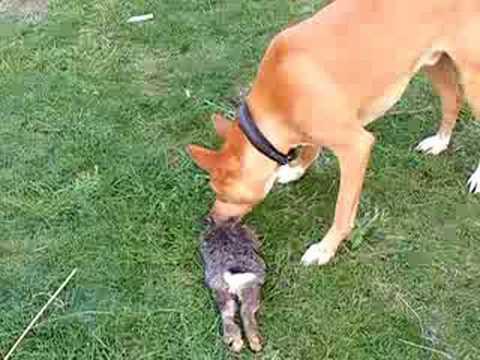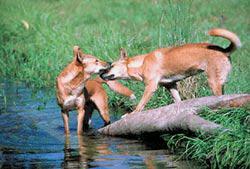The first image is the image on the left, the second image is the image on the right. Assess this claim about the two images: "There is at least one dingo dog laying down.". Correct or not? Answer yes or no. No. 